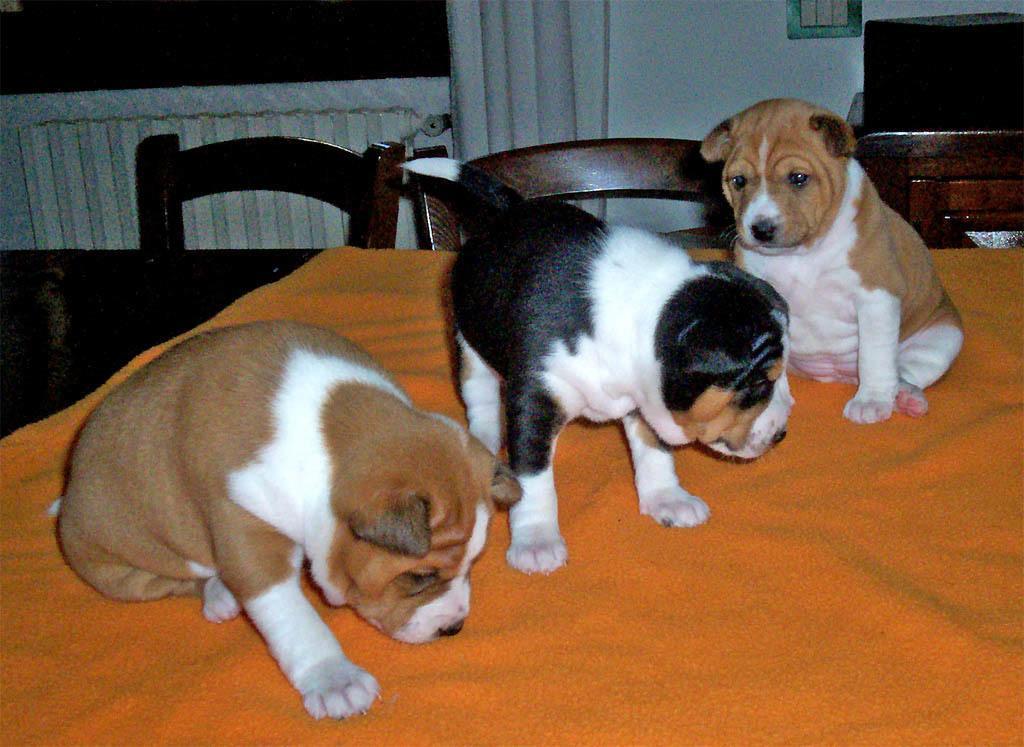Can you describe this image briefly? These are dogs on the cloth, these are chairs. 